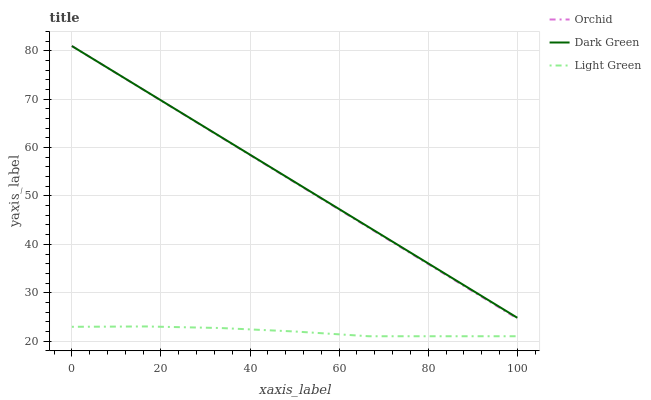Does Light Green have the minimum area under the curve?
Answer yes or no. Yes. Does Dark Green have the maximum area under the curve?
Answer yes or no. Yes. Does Orchid have the minimum area under the curve?
Answer yes or no. No. Does Orchid have the maximum area under the curve?
Answer yes or no. No. Is Orchid the smoothest?
Answer yes or no. Yes. Is Light Green the roughest?
Answer yes or no. Yes. Is Light Green the smoothest?
Answer yes or no. No. Is Orchid the roughest?
Answer yes or no. No. Does Light Green have the lowest value?
Answer yes or no. Yes. Does Orchid have the lowest value?
Answer yes or no. No. Does Orchid have the highest value?
Answer yes or no. Yes. Does Light Green have the highest value?
Answer yes or no. No. Is Light Green less than Orchid?
Answer yes or no. Yes. Is Orchid greater than Light Green?
Answer yes or no. Yes. Does Orchid intersect Dark Green?
Answer yes or no. Yes. Is Orchid less than Dark Green?
Answer yes or no. No. Is Orchid greater than Dark Green?
Answer yes or no. No. Does Light Green intersect Orchid?
Answer yes or no. No. 